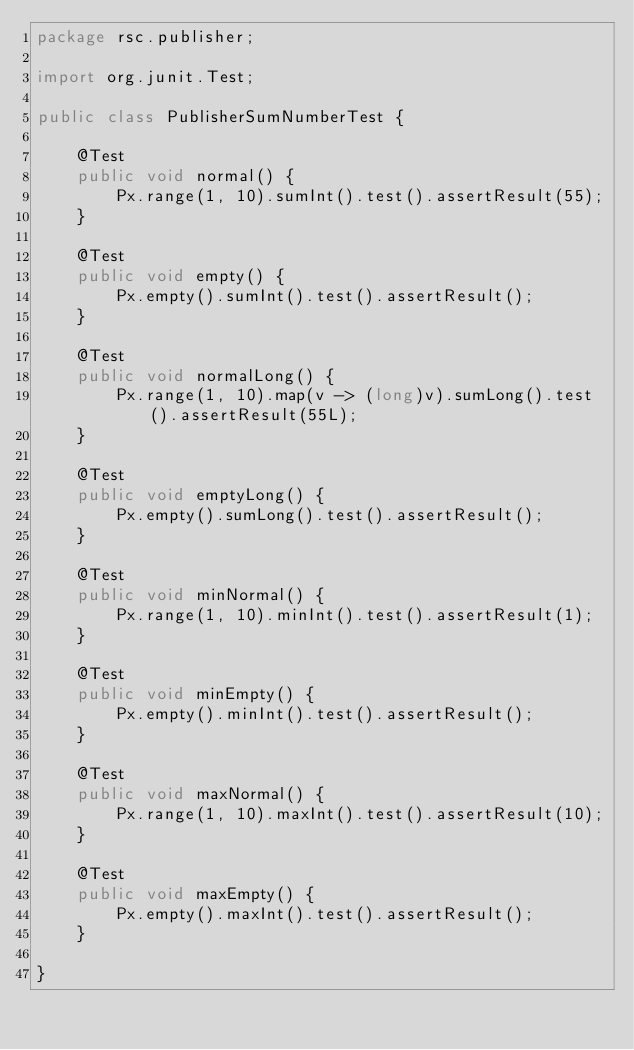Convert code to text. <code><loc_0><loc_0><loc_500><loc_500><_Java_>package rsc.publisher;

import org.junit.Test;

public class PublisherSumNumberTest {

    @Test
    public void normal() {
        Px.range(1, 10).sumInt().test().assertResult(55);
    }

    @Test
    public void empty() {
        Px.empty().sumInt().test().assertResult();
    }

    @Test
    public void normalLong() {
        Px.range(1, 10).map(v -> (long)v).sumLong().test().assertResult(55L);
    }

    @Test
    public void emptyLong() {
        Px.empty().sumLong().test().assertResult();
    }

    @Test
    public void minNormal() {
        Px.range(1, 10).minInt().test().assertResult(1);
    }

    @Test
    public void minEmpty() {
        Px.empty().minInt().test().assertResult();
    }

    @Test
    public void maxNormal() {
        Px.range(1, 10).maxInt().test().assertResult(10);
    }

    @Test
    public void maxEmpty() {
        Px.empty().maxInt().test().assertResult();
    }

}
</code> 